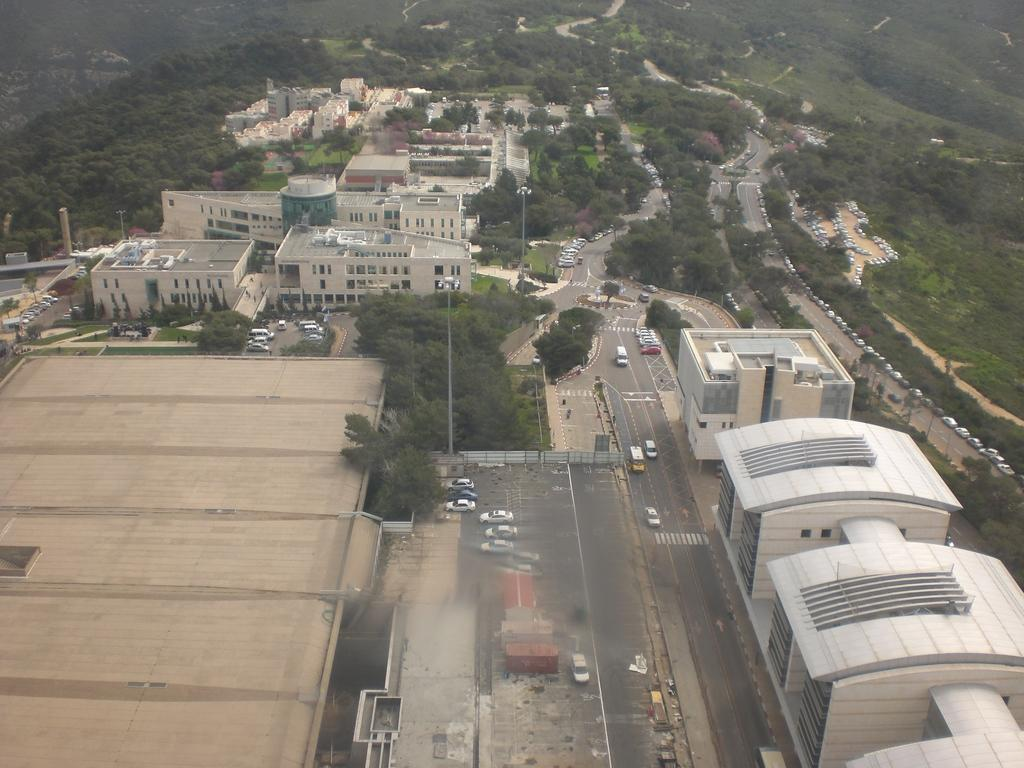What is the main feature in the center of the image? There is a road in the center of the image. What types of vehicles can be seen on the road? Cars and buses are present on the road. What other elements can be seen in the image besides the road and vehicles? There are trees, buildings, poles, and hills visible in the image. Can you hear the sound of thunder in the image? There is no sound present in the image, so it is not possible to determine if thunder can be heard. 